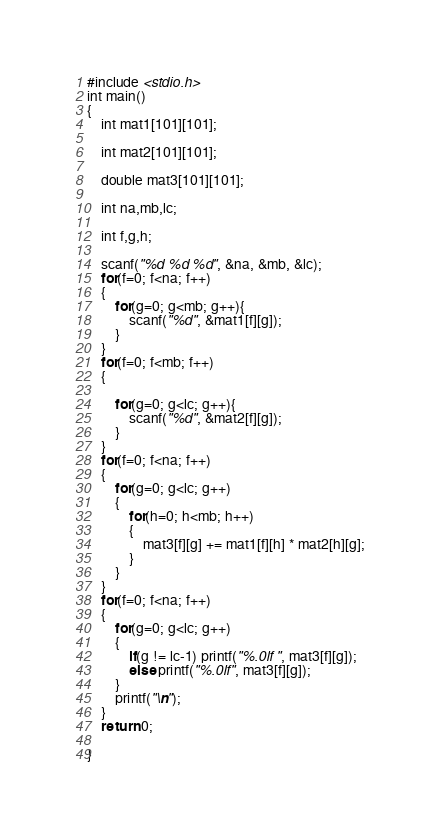<code> <loc_0><loc_0><loc_500><loc_500><_C_>#include <stdio.h>
int main()
{
    int mat1[101][101];

    int mat2[101][101];

    double mat3[101][101];

    int na,mb,lc;

    int f,g,h;

    scanf("%d %d %d", &na, &mb, &lc);
    for(f=0; f<na; f++)
    {
        for(g=0; g<mb; g++){
            scanf("%d", &mat1[f][g]);
        }
    }
    for(f=0; f<mb; f++)
    {

        for(g=0; g<lc; g++){
            scanf("%d", &mat2[f][g]);
        }
    }
    for(f=0; f<na; f++)
    {
        for(g=0; g<lc; g++)
        {
            for(h=0; h<mb; h++)
            {
                mat3[f][g] += mat1[f][h] * mat2[h][g];
            }
        }
    }
    for(f=0; f<na; f++)
    {
        for(g=0; g<lc; g++)
        {
            if(g != lc-1) printf("%.0lf ", mat3[f][g]);
            else printf("%.0lf", mat3[f][g]);
        }
        printf("\n");
    }
    return 0;

}


</code> 